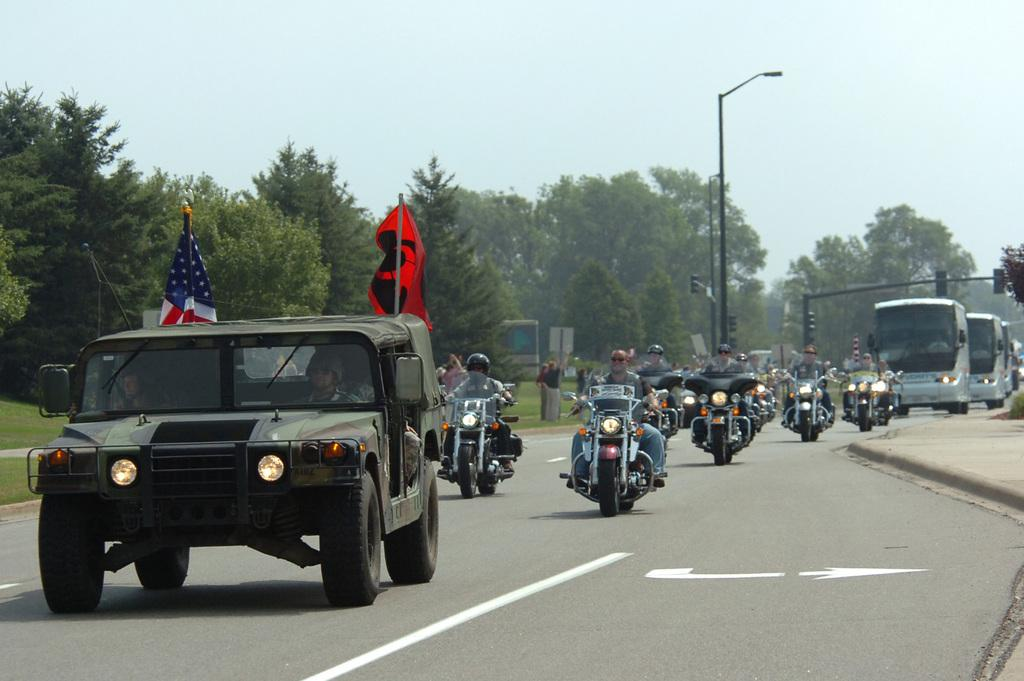What type of vehicle is in the image? There is a jeep in the image. What additional objects are present in the image? There are flags, people, motorcycles, buses, a street lamp, a traffic signal, trees, grass, and sky visible in the image. What shape is the mom's balance in the image? There is no mom or balance present in the image. 